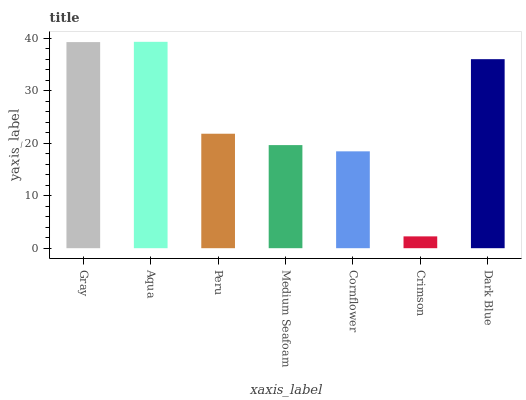Is Crimson the minimum?
Answer yes or no. Yes. Is Aqua the maximum?
Answer yes or no. Yes. Is Peru the minimum?
Answer yes or no. No. Is Peru the maximum?
Answer yes or no. No. Is Aqua greater than Peru?
Answer yes or no. Yes. Is Peru less than Aqua?
Answer yes or no. Yes. Is Peru greater than Aqua?
Answer yes or no. No. Is Aqua less than Peru?
Answer yes or no. No. Is Peru the high median?
Answer yes or no. Yes. Is Peru the low median?
Answer yes or no. Yes. Is Aqua the high median?
Answer yes or no. No. Is Dark Blue the low median?
Answer yes or no. No. 